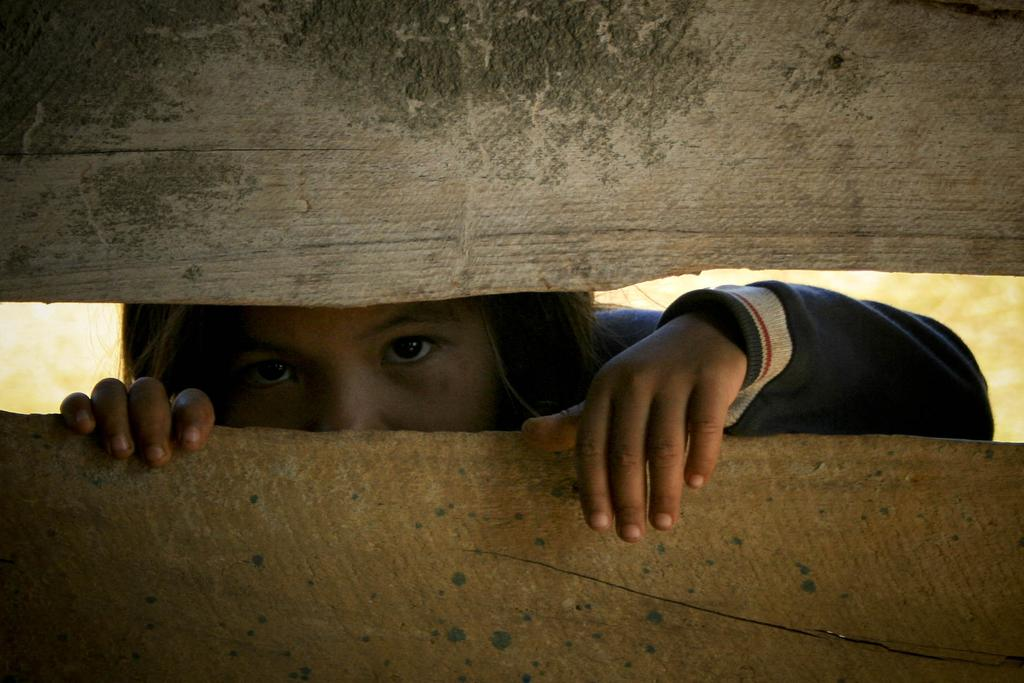Who is the main subject in the image? There is a girl in the image. What is the girl doing in the image? The girl is looking through a hole. Can you describe the hole in the image? The hole is between two wooden sticks. What type of square object can be seen on the girl's leg in the image? There is no square object visible on the girl's leg in the image. 